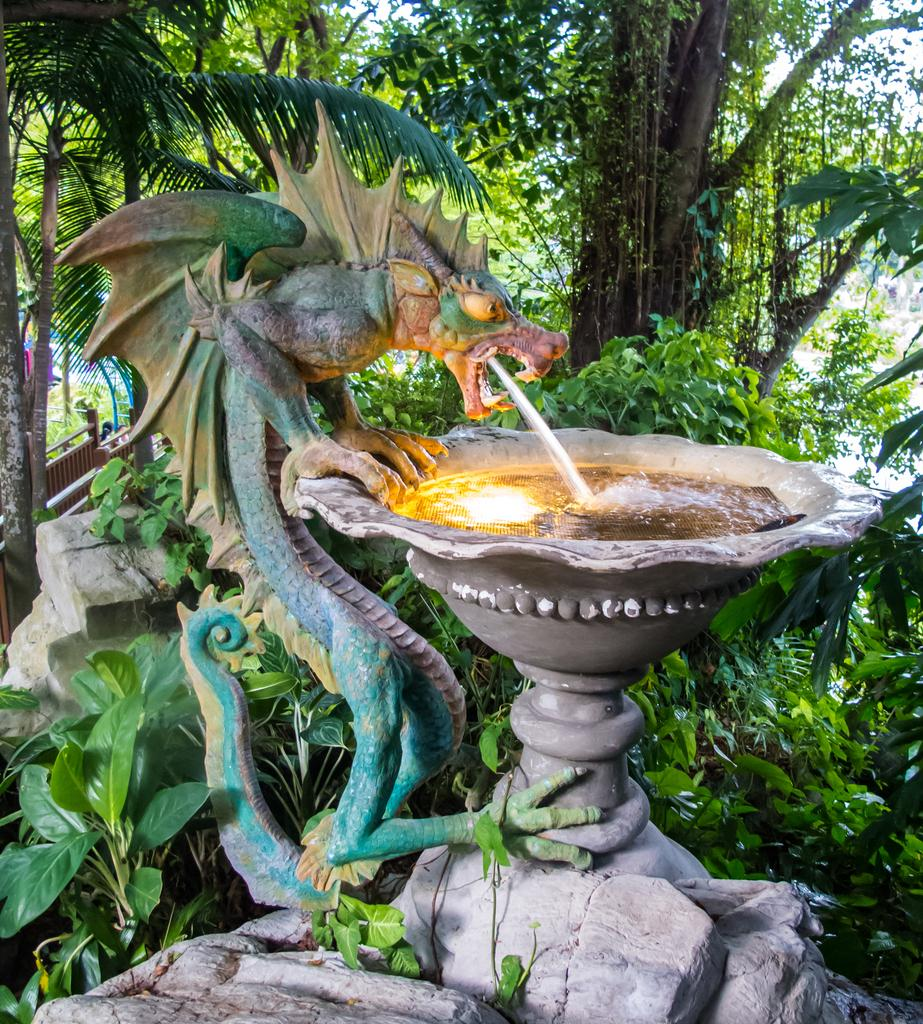What is the main feature in the center of the image? There is a fountain in the center of the image. What can be seen in the background of the image? There are trees in the background of the image. What type of natural elements are visible at the bottom of the image? Rocks are visible at the bottom of the image. How many children are playing near the fountain in the image? There are no children present in the image; it only features a fountain, trees, and rocks. What type of camp can be seen in the image? There is no camp present in the image. 